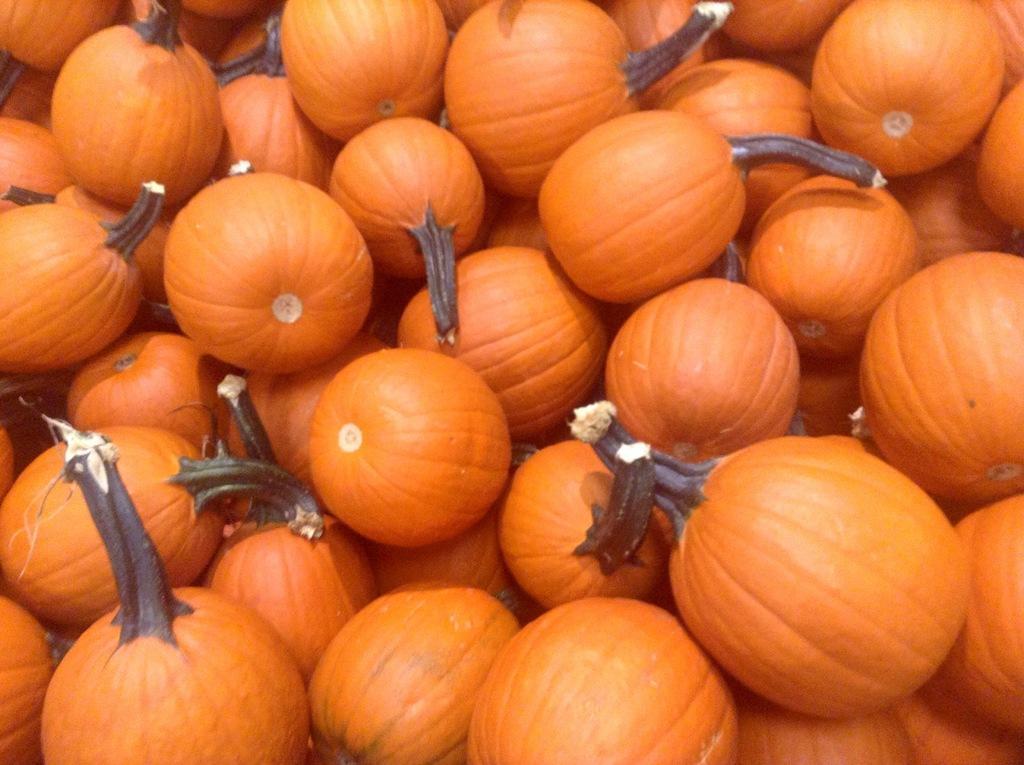How would you summarize this image in a sentence or two? In this picture we can see there are some pumpkins. 